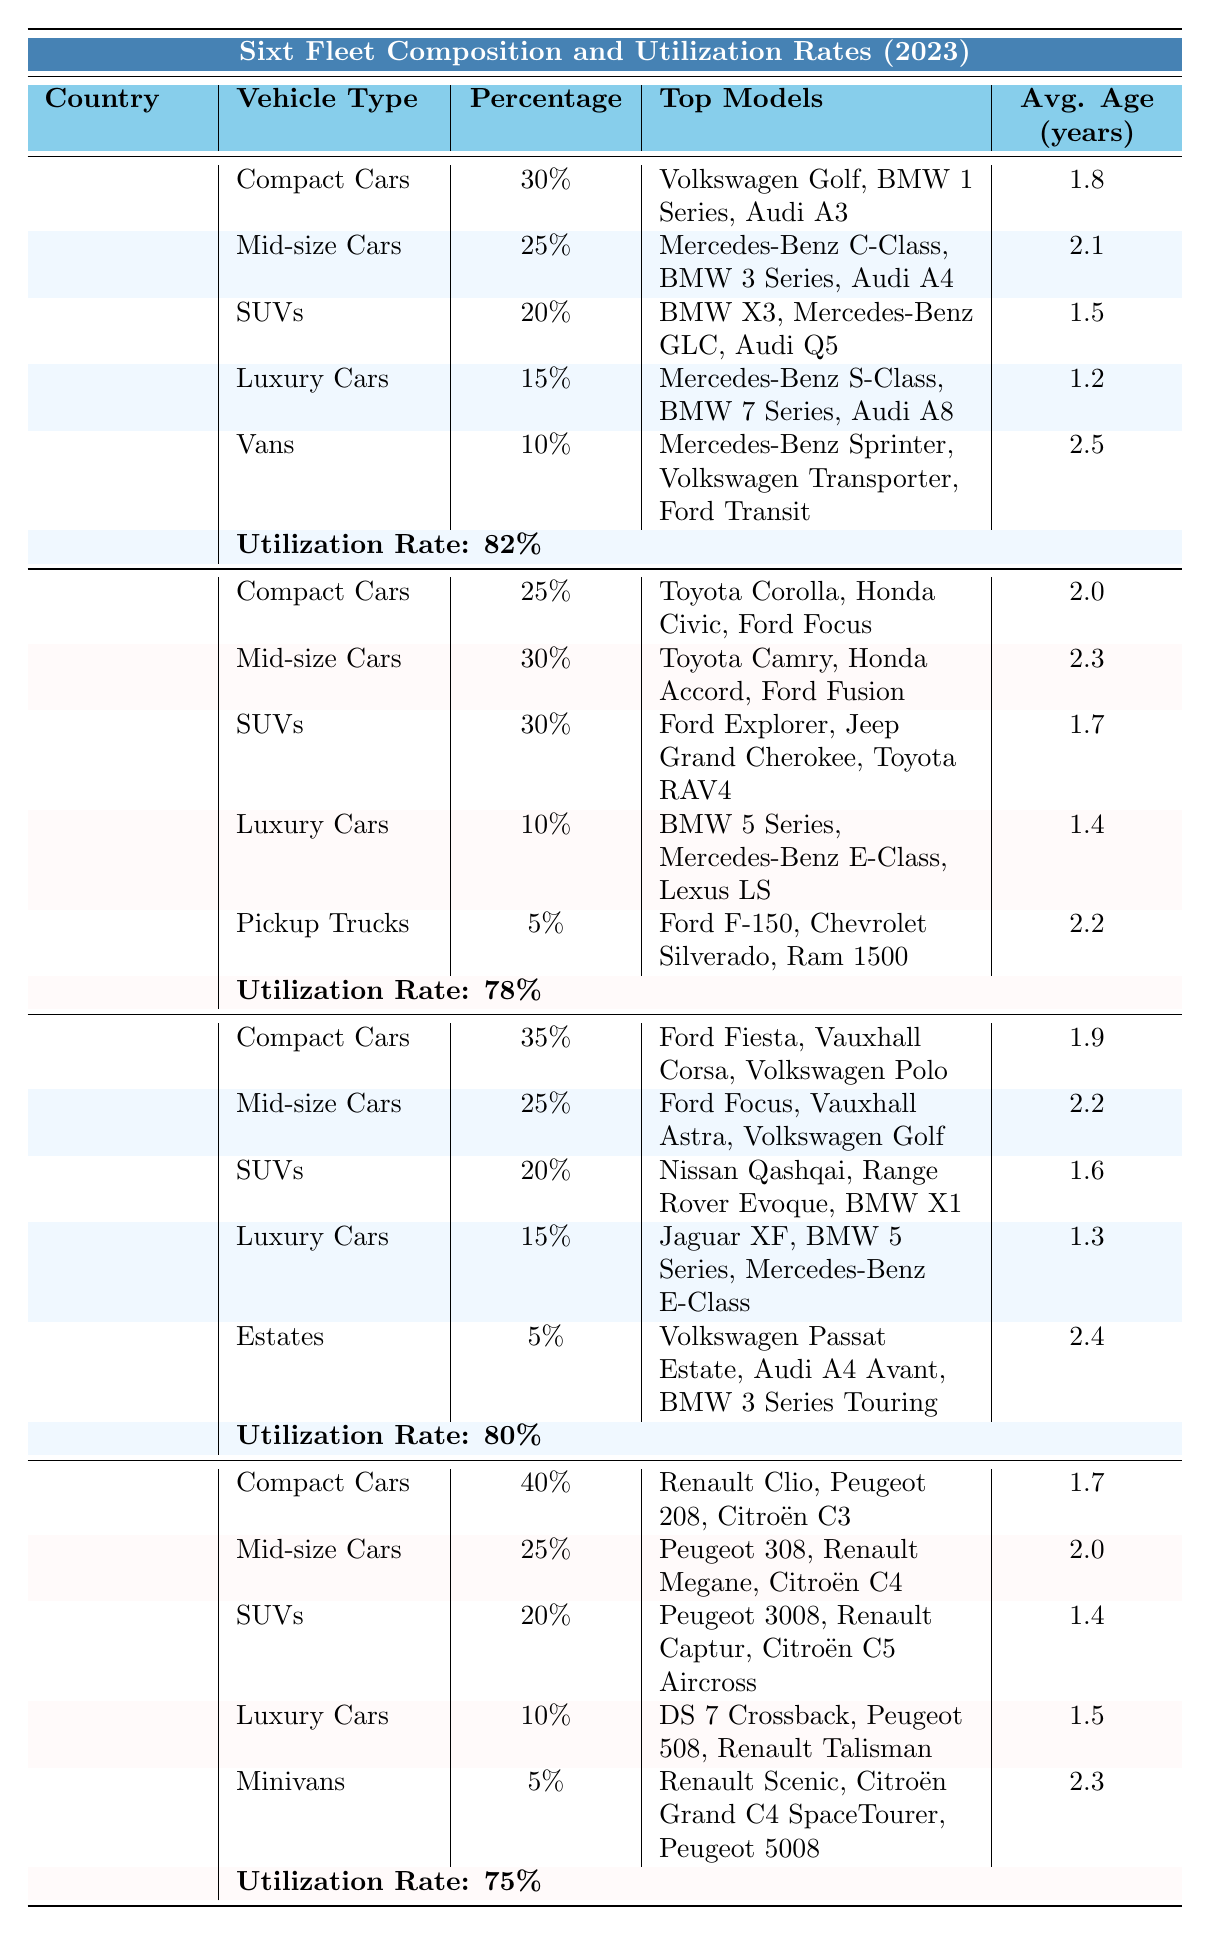What is the utilization rate in Germany? The table shows that Germany has a utilization rate of 82%.
Answer: 82% Which country has the highest percentage of Compact Cars? According to the table, France has the highest percentage of Compact Cars at 40%.
Answer: France What are the top models of Mid-size Cars in the United States? The table lists the top models for Mid-size Cars in the United States as Toyota Camry, Honda Accord, and Ford Fusion.
Answer: Toyota Camry, Honda Accord, Ford Fusion How many different vehicle types are listed for the United Kingdom? The table shows that there are five vehicle types listed for the United Kingdom: Compact Cars, Mid-size Cars, SUVs, Luxury Cars, and Estates.
Answer: 5 Which country's Luxury Cars have the lowest average age? Germany's Luxury Cars have the lowest average age at 1.2 years compared to other countries.
Answer: Germany What is the average percentage of SUVs across all listed countries? By calculating the percentages of SUVs: (20% Germany + 30% United States + 20% United Kingdom + 20% France) / 4 = 22.5%.
Answer: 22.5% Is the average age of Vans in Germany higher than in France? The average age of Vans in Germany is 2.5 years, while France has no Vans listed. Thus, comparing is not valid; but without Vans in France, 2.5 years is considered higher.
Answer: Yes How do the utilization rates compare between the United States and France? The United States has a utilization rate of 78%, while France has a rate of 75%. Therefore, the U.S. has a higher utilization rate than France.
Answer: United States higher What is the combined percentage of Luxury Cars and Vans in Germany? The combined percentage is 15% (Luxury Cars) + 10% (Vans) = 25%.
Answer: 25% Which vehicle type has the highest average age in the United Kingdom? In the United Kingdom, Estates have the highest average age at 2.4 years.
Answer: Estates 